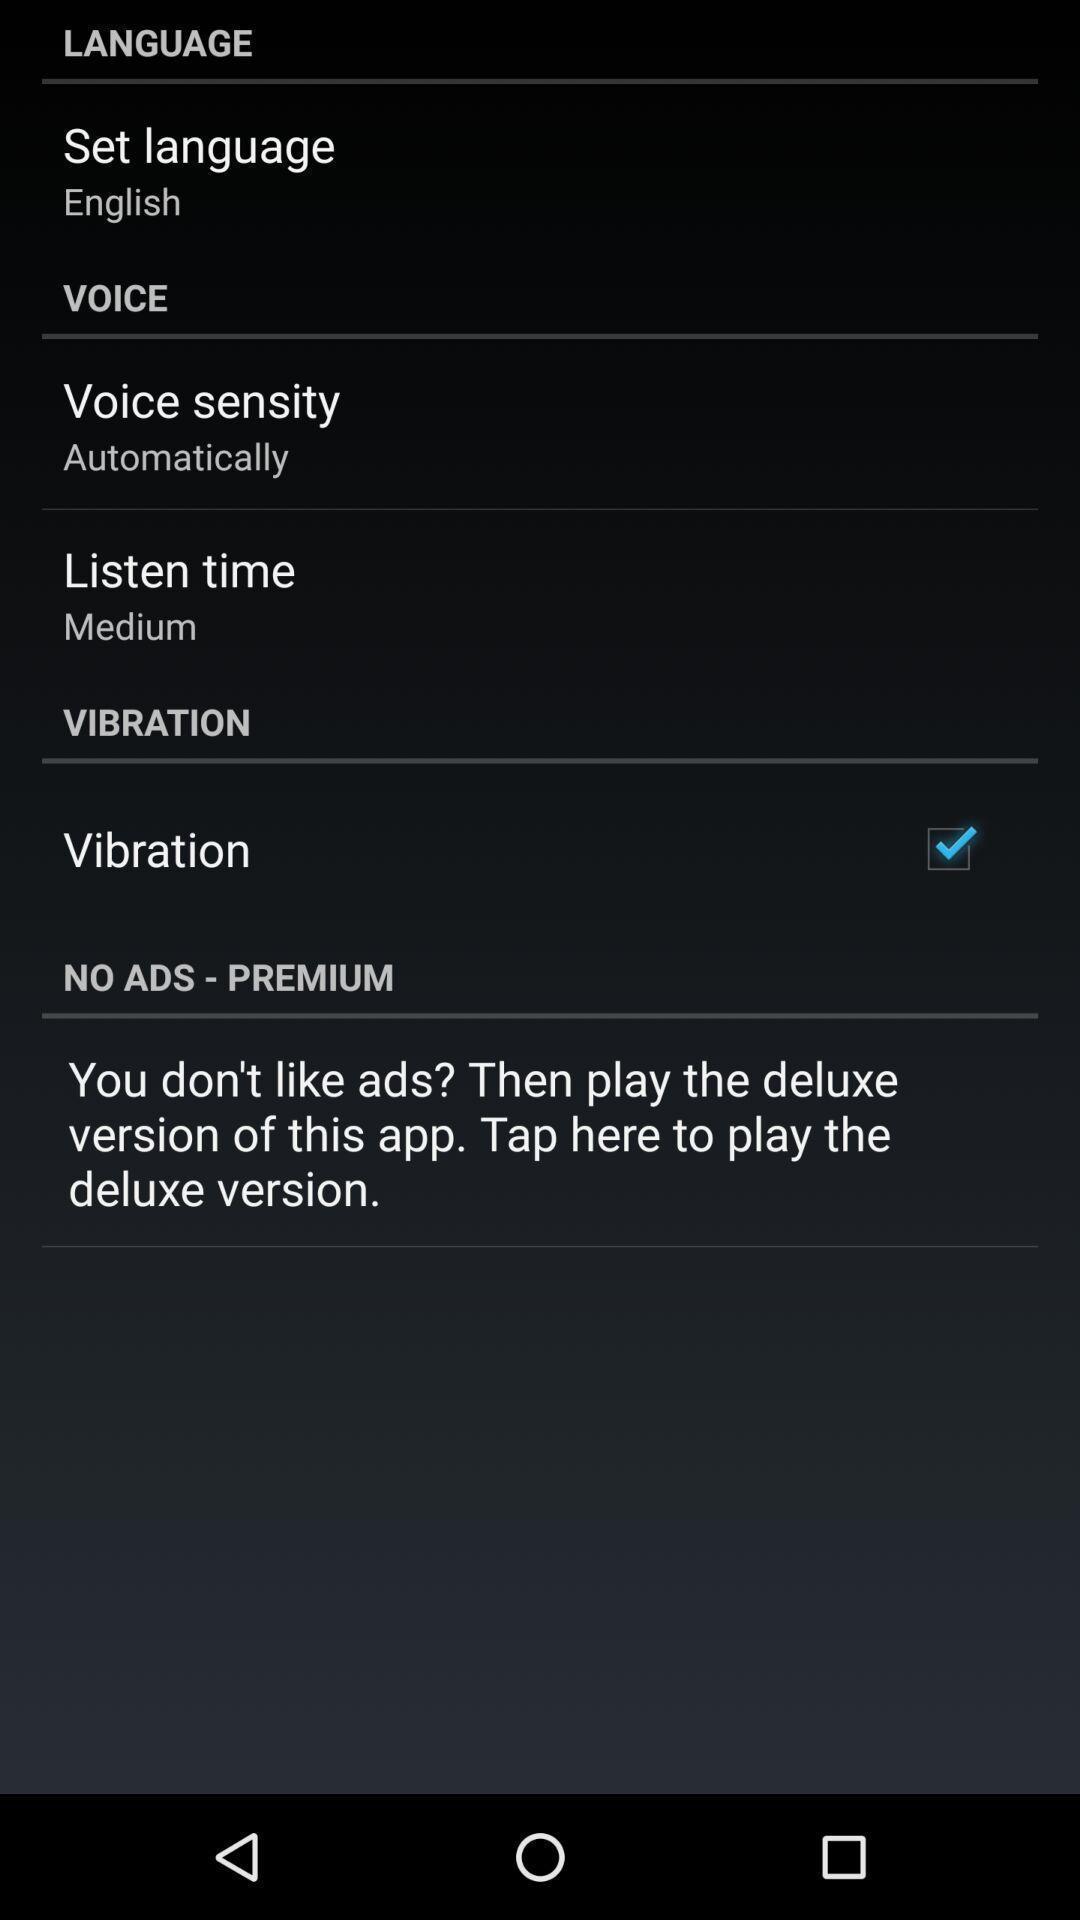Give me a narrative description of this picture. Screen showing languages settings page. 